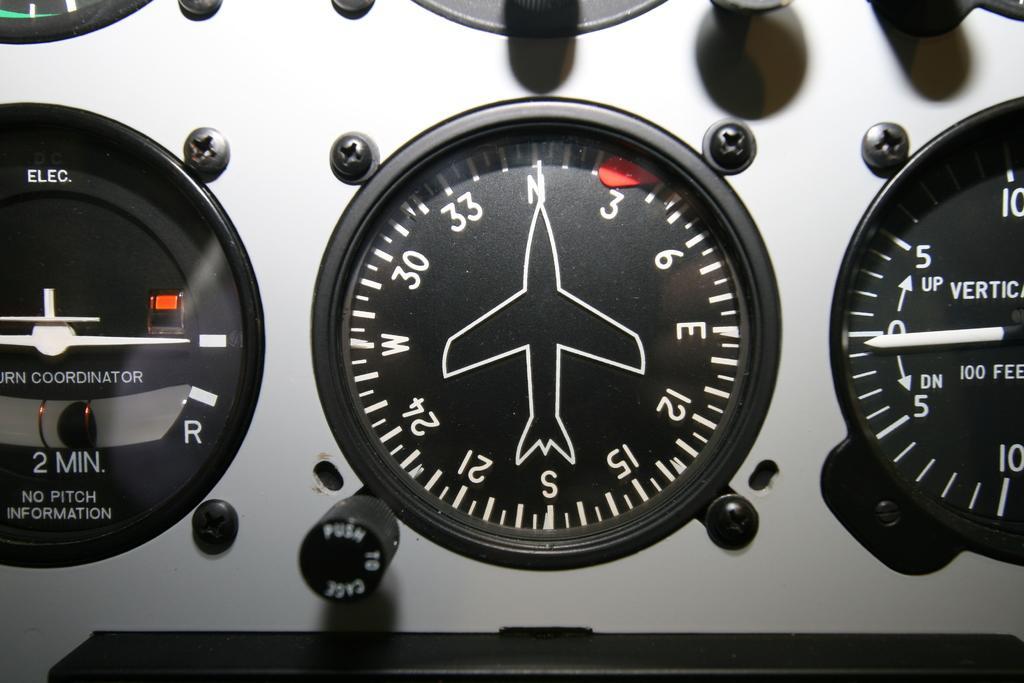Please provide a concise description of this image. In the picture we can see some Speed-o- meters and in one we can see a fuel injection and other we can see a direction and beside it, we can see another meter with some readings in it and a push button below the second meter. 